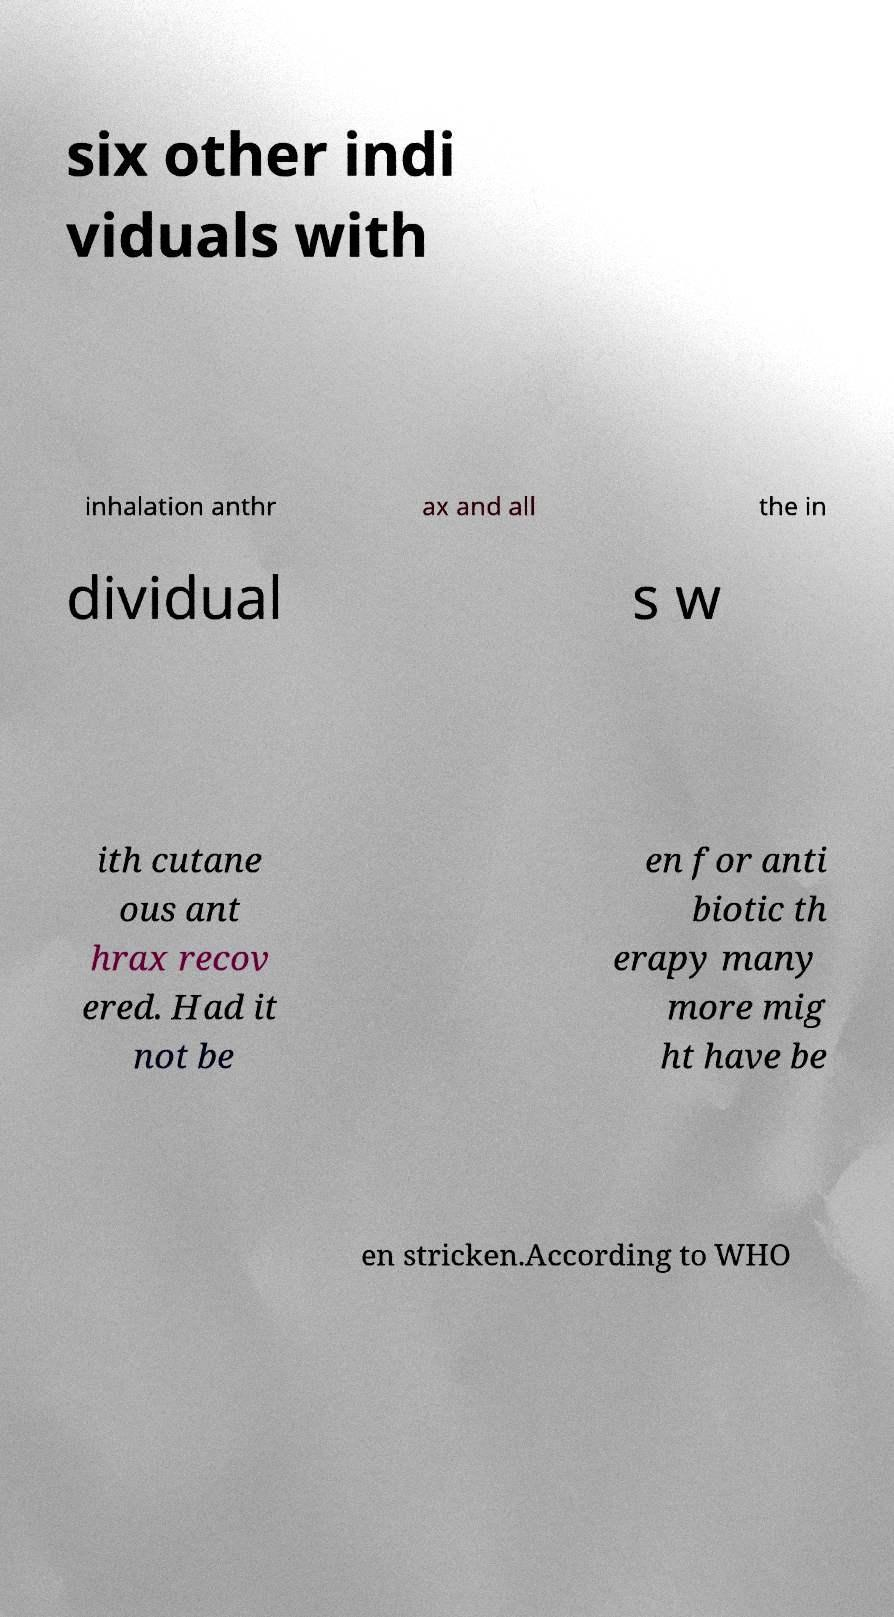What messages or text are displayed in this image? I need them in a readable, typed format. six other indi viduals with inhalation anthr ax and all the in dividual s w ith cutane ous ant hrax recov ered. Had it not be en for anti biotic th erapy many more mig ht have be en stricken.According to WHO 